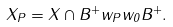<formula> <loc_0><loc_0><loc_500><loc_500>X _ { P } = X \cap B ^ { + } w _ { P } w _ { 0 } B ^ { + } .</formula> 